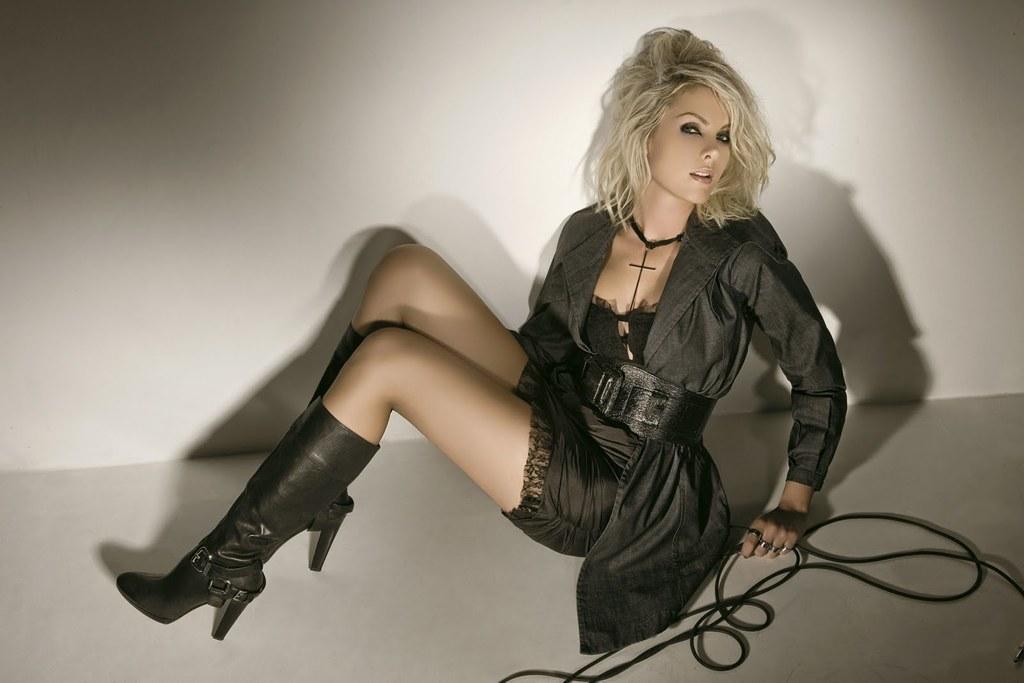In one or two sentences, can you explain what this image depicts? In the image there is a lady sitting on the floor. She is holding a black color rope in her hand. And she wore boots. 